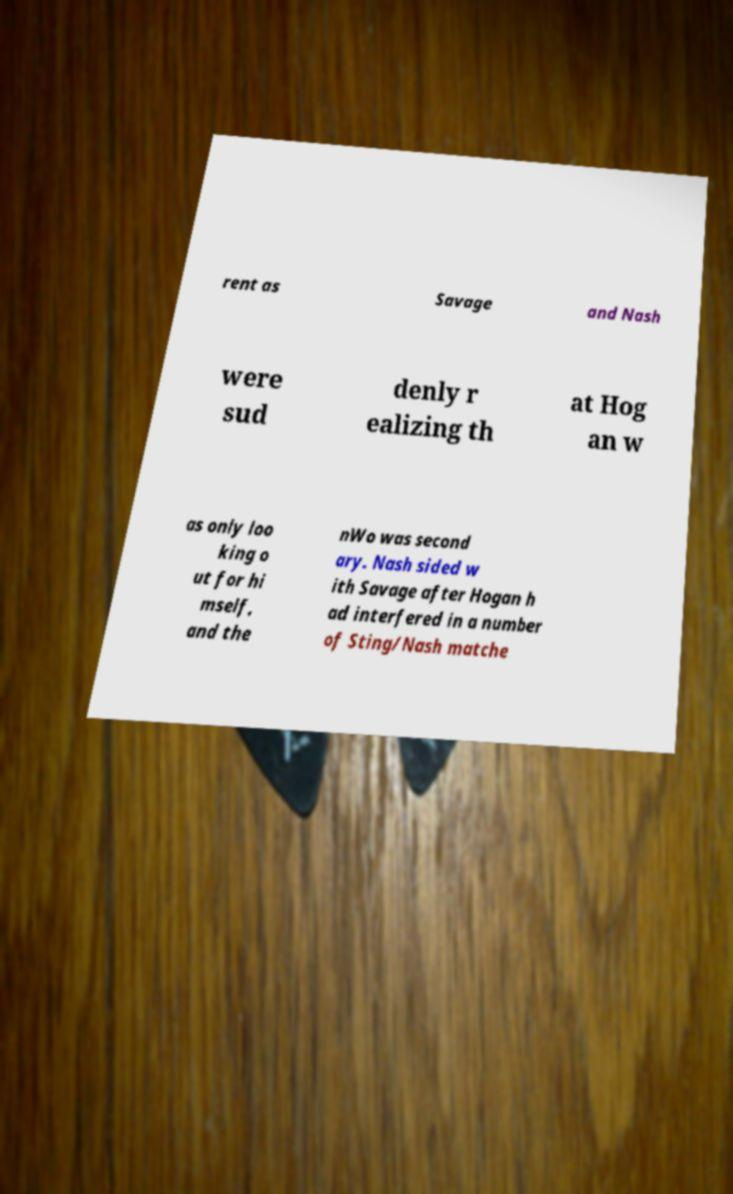I need the written content from this picture converted into text. Can you do that? rent as Savage and Nash were sud denly r ealizing th at Hog an w as only loo king o ut for hi mself, and the nWo was second ary. Nash sided w ith Savage after Hogan h ad interfered in a number of Sting/Nash matche 